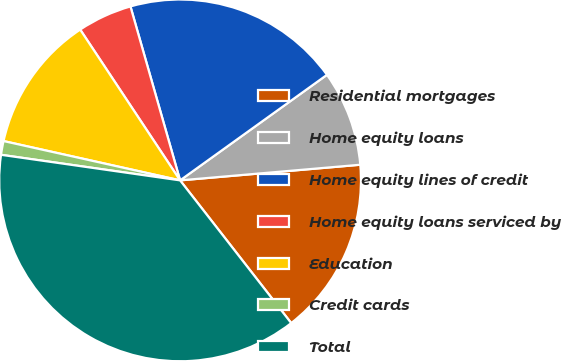Convert chart to OTSL. <chart><loc_0><loc_0><loc_500><loc_500><pie_chart><fcel>Residential mortgages<fcel>Home equity loans<fcel>Home equity lines of credit<fcel>Home equity loans serviced by<fcel>Education<fcel>Credit cards<fcel>Total<nl><fcel>15.85%<fcel>8.54%<fcel>19.51%<fcel>4.89%<fcel>12.2%<fcel>1.23%<fcel>37.79%<nl></chart> 